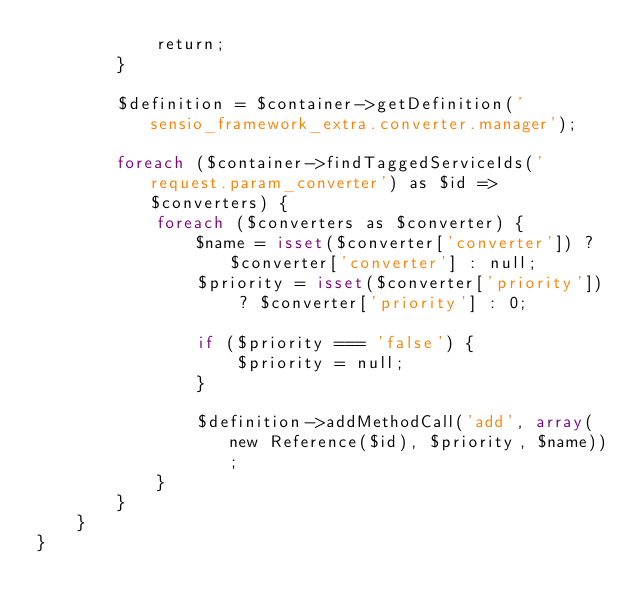<code> <loc_0><loc_0><loc_500><loc_500><_PHP_>            return;
        }

        $definition = $container->getDefinition('sensio_framework_extra.converter.manager');

        foreach ($container->findTaggedServiceIds('request.param_converter') as $id => $converters) {
            foreach ($converters as $converter) {
                $name = isset($converter['converter']) ? $converter['converter'] : null;
                $priority = isset($converter['priority']) ? $converter['priority'] : 0;

                if ($priority === 'false') {
                    $priority = null;
                }

                $definition->addMethodCall('add', array(new Reference($id), $priority, $name));
            }
        }
    }
}
</code> 